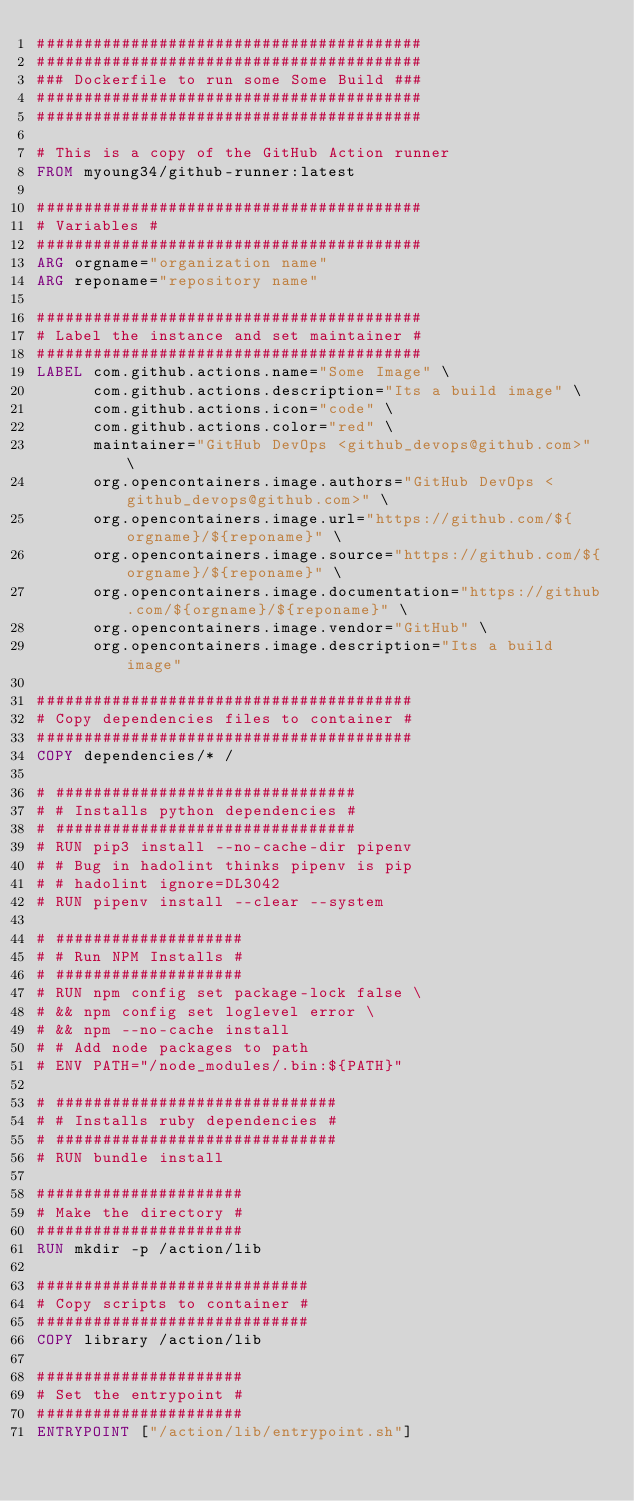<code> <loc_0><loc_0><loc_500><loc_500><_Dockerfile_>#########################################
#########################################
### Dockerfile to run some Some Build ###
#########################################
#########################################

# This is a copy of the GitHub Action runner
FROM myoung34/github-runner:latest

#########################################
# Variables #
#########################################
ARG orgname="organization name"
ARG reponame="repository name"

#########################################
# Label the instance and set maintainer #
#########################################
LABEL com.github.actions.name="Some Image" \
      com.github.actions.description="Its a build image" \
      com.github.actions.icon="code" \
      com.github.actions.color="red" \
      maintainer="GitHub DevOps <github_devops@github.com>" \
      org.opencontainers.image.authors="GitHub DevOps <github_devops@github.com>" \
      org.opencontainers.image.url="https://github.com/${orgname}/${reponame}" \
      org.opencontainers.image.source="https://github.com/${orgname}/${reponame}" \
      org.opencontainers.image.documentation="https://github.com/${orgname}/${reponame}" \
      org.opencontainers.image.vendor="GitHub" \
      org.opencontainers.image.description="Its a build image"

########################################
# Copy dependencies files to container #
########################################
COPY dependencies/* /

# ################################
# # Installs python dependencies #
# ################################
# RUN pip3 install --no-cache-dir pipenv
# # Bug in hadolint thinks pipenv is pip
# # hadolint ignore=DL3042
# RUN pipenv install --clear --system

# ####################
# # Run NPM Installs #
# ####################
# RUN npm config set package-lock false \
# && npm config set loglevel error \
# && npm --no-cache install
# # Add node packages to path
# ENV PATH="/node_modules/.bin:${PATH}"

# ##############################
# # Installs ruby dependencies #
# ##############################
# RUN bundle install

######################
# Make the directory #
######################
RUN mkdir -p /action/lib

#############################
# Copy scripts to container #
#############################
COPY library /action/lib

######################
# Set the entrypoint #
######################
ENTRYPOINT ["/action/lib/entrypoint.sh"]
</code> 